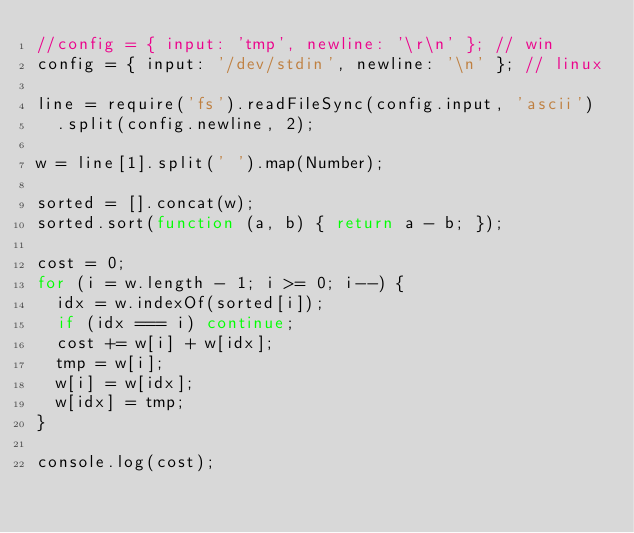Convert code to text. <code><loc_0><loc_0><loc_500><loc_500><_JavaScript_>//config = { input: 'tmp', newline: '\r\n' }; // win
config = { input: '/dev/stdin', newline: '\n' }; // linux

line = require('fs').readFileSync(config.input, 'ascii')
  .split(config.newline, 2);

w = line[1].split(' ').map(Number);

sorted = [].concat(w);
sorted.sort(function (a, b) { return a - b; });

cost = 0;
for (i = w.length - 1; i >= 0; i--) {
  idx = w.indexOf(sorted[i]);
  if (idx === i) continue;
  cost += w[i] + w[idx];
  tmp = w[i];
  w[i] = w[idx];
  w[idx] = tmp;
}

console.log(cost);</code> 